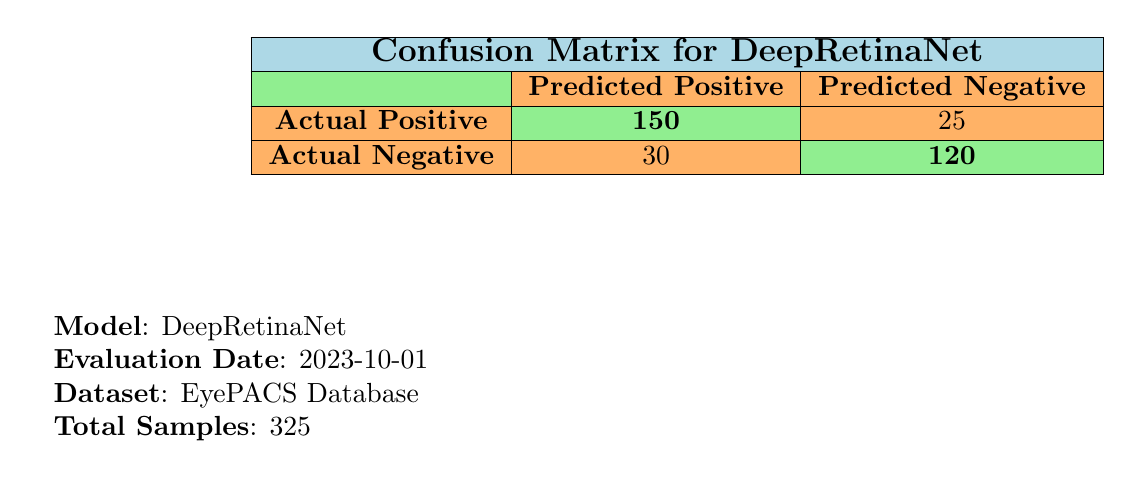What is the number of true positives in the confusion matrix? The table shows that the true positives are listed under "Actual Positive" in the "Predicted Positive" column. The value is 150.
Answer: 150 What is the number of false negatives in the confusion matrix? In the table, false negatives are found under "Actual Positive" in the "Predicted Negative" column. The value is 25.
Answer: 25 What is the total number of samples evaluated? The total number of samples is indicated in the notes below the table, which states the total samples evaluated are 325.
Answer: 325 Is the model DeepRetinaNet effective in reducing false positives? To determine efficiency in reducing false positives, we compare the number of false positives (30) and the true negatives (120). A lower number of false positives relative to true negatives indicates effectiveness. In this case, yes, it has a reasonable rate of false positives relative to true negatives.
Answer: Yes What is the sum of true positives and true negatives? The sum can be calculated by adding the values of true positives (150) and true negatives (120) together. So, 150 + 120 = 270.
Answer: 270 How many actual positives are there based on the confusion matrix? Actual positives can be found by adding true positives and false negatives. True positives are 150 and false negatives are 25, so 150 + 25 = 175.
Answer: 175 What percentage of total samples are false positives? The percentage is calculated by taking the number of false positives (30), dividing it by the total samples (325), and then multiplying by 100. (30 / 325) * 100 = 9.23%.
Answer: 9.23% What are the predicted negative outcomes in total? The total of predicted negatives includes true negatives and false negatives, which are 120 and 25, respectively. So, their sum is 120 + 25 = 145.
Answer: 145 How does the number of predicted positives compare to predicted negatives? We compare the number of predicted positives (true positives plus false positives: 150 + 30 = 180) to predicted negatives (true negatives plus false negatives: 120 + 25 = 145). Predicted positives (180) are greater than predicted negatives (145).
Answer: Predicted positives are greater 